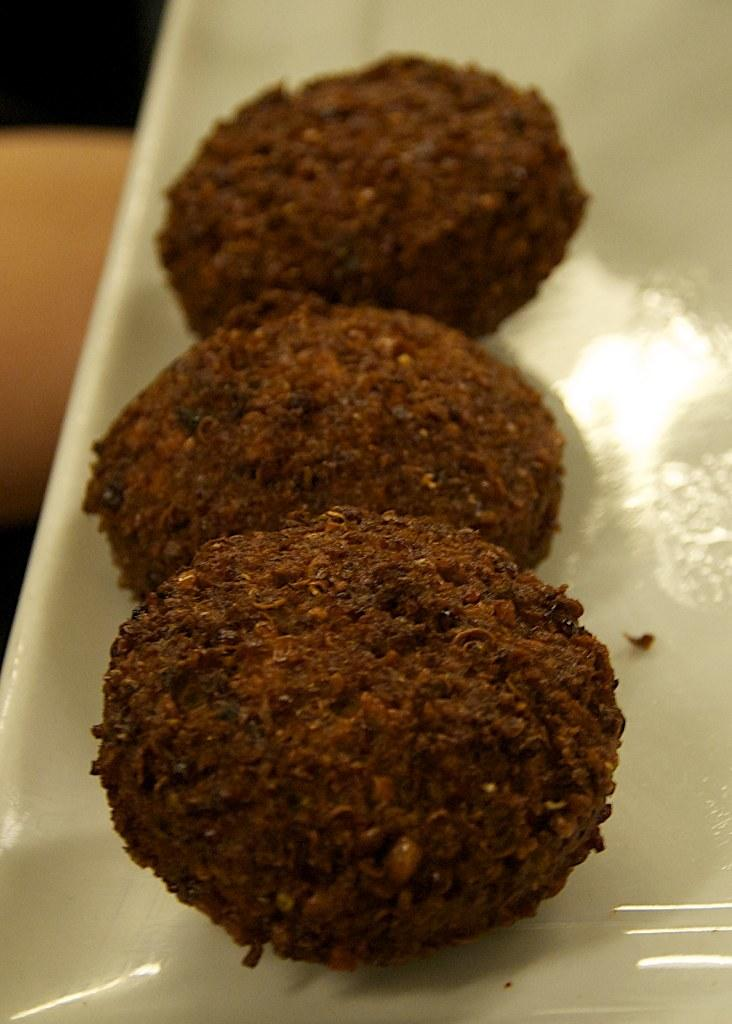What is on the plate in the image? There are food items on a plate in the image. What can be seen below the plate in the image? The ground is visible in the image. What is located on the left side of the image? There is an object on the left side of the image. Can you describe the dock in the image? There is no dock present in the image. 